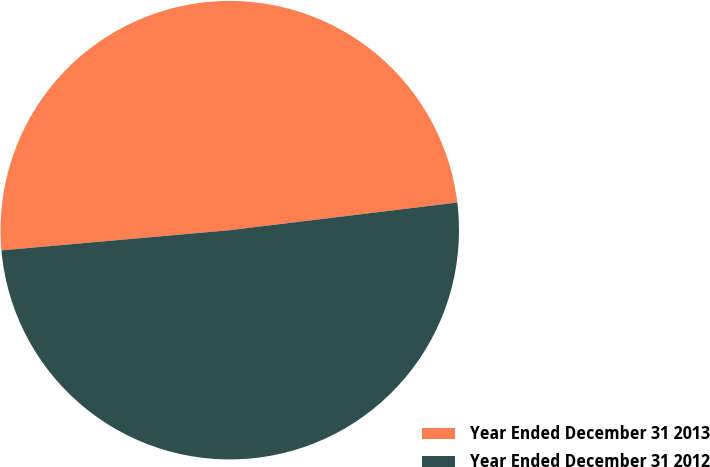Convert chart. <chart><loc_0><loc_0><loc_500><loc_500><pie_chart><fcel>Year Ended December 31 2013<fcel>Year Ended December 31 2012<nl><fcel>49.48%<fcel>50.52%<nl></chart> 